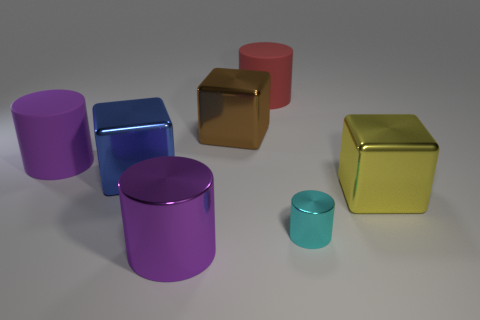Subtract all yellow cylinders. Subtract all red balls. How many cylinders are left? 4 Add 3 large brown things. How many objects exist? 10 Subtract all blocks. How many objects are left? 4 Subtract all large blue spheres. Subtract all purple cylinders. How many objects are left? 5 Add 2 tiny shiny things. How many tiny shiny things are left? 3 Add 2 brown things. How many brown things exist? 3 Subtract 0 red blocks. How many objects are left? 7 